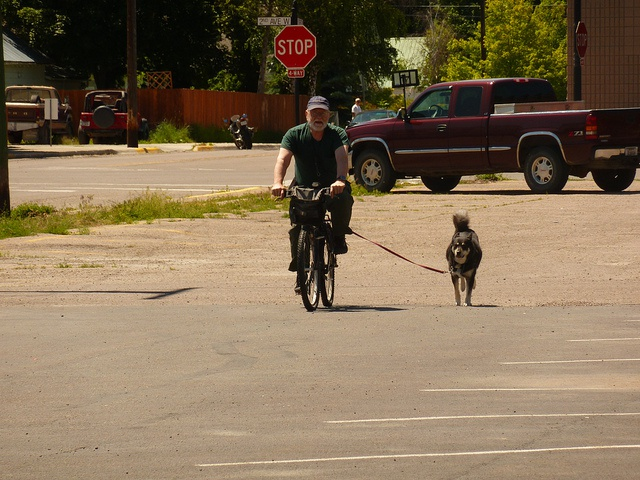Describe the objects in this image and their specific colors. I can see truck in black, maroon, gray, and olive tones, people in black, maroon, gray, and tan tones, bicycle in black, gray, and tan tones, truck in black, maroon, and gray tones, and car in black, maroon, olive, and gray tones in this image. 